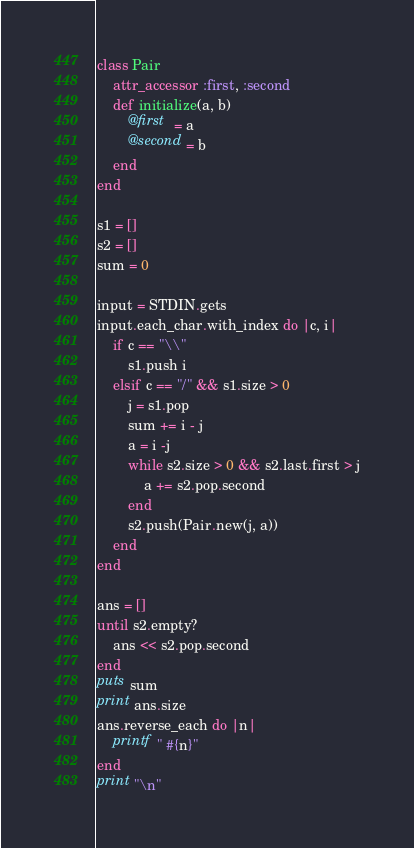Convert code to text. <code><loc_0><loc_0><loc_500><loc_500><_Ruby_>class Pair
	attr_accessor :first, :second
	def initialize(a, b)
		@first  = a
		@second = b
	end
end

s1 = []
s2 = []
sum = 0

input = STDIN.gets
input.each_char.with_index do |c, i|
	if c == "\\"
		s1.push i
	elsif c == "/" && s1.size > 0
		j = s1.pop
		sum += i - j
		a = i -j
		while s2.size > 0 && s2.last.first > j
			a += s2.pop.second
		end
		s2.push(Pair.new(j, a))
	end
end

ans = []
until s2.empty?
	ans << s2.pop.second
end
puts sum
print ans.size
ans.reverse_each do |n|
	printf " #{n}"
end
print "\n"</code> 